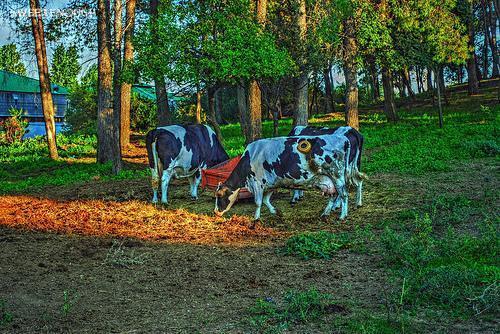How many cows are visible in this photo?
Give a very brief answer. 3. 